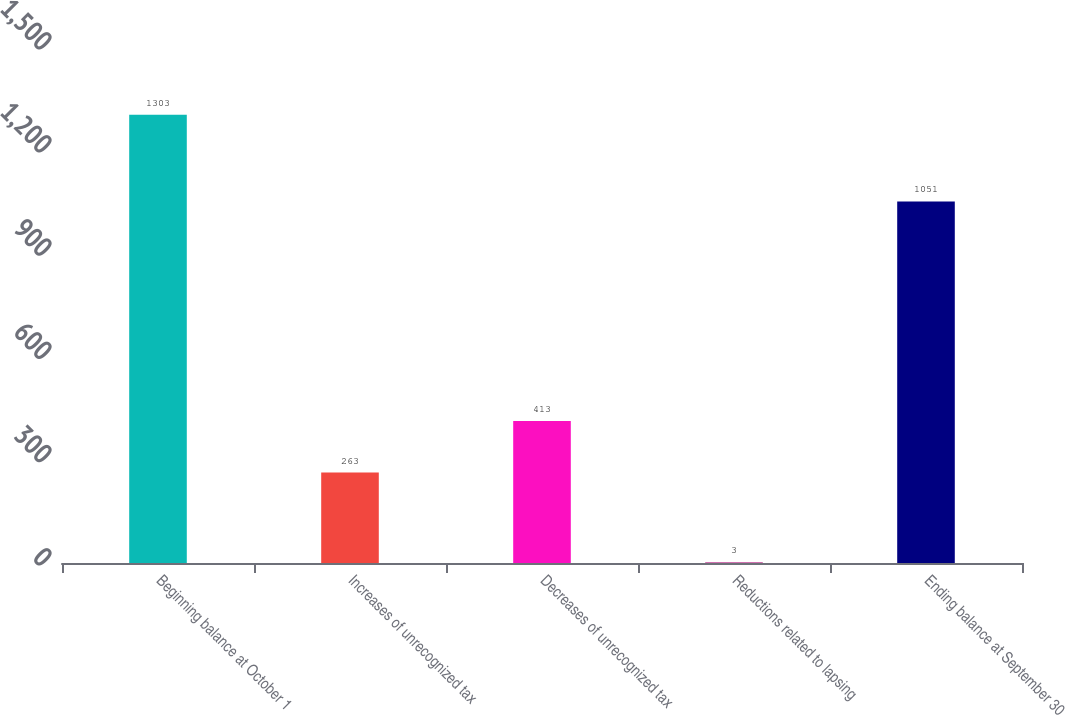<chart> <loc_0><loc_0><loc_500><loc_500><bar_chart><fcel>Beginning balance at October 1<fcel>Increases of unrecognized tax<fcel>Decreases of unrecognized tax<fcel>Reductions related to lapsing<fcel>Ending balance at September 30<nl><fcel>1303<fcel>263<fcel>413<fcel>3<fcel>1051<nl></chart> 